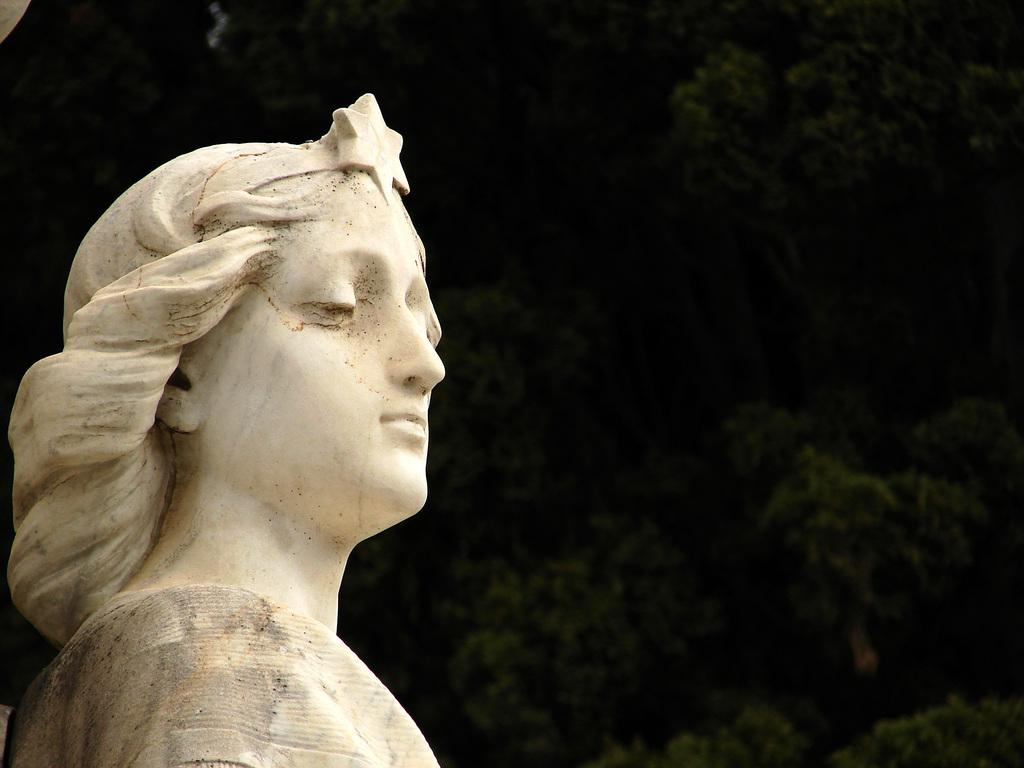What is the main subject in the image? There is a statue in the image. What is the color of the statue? The statue is white in color. What can be seen in the background of the image? There are trees in the background of the image. What type of pot is being held by the statue's hand in the image? There is no pot or hand visible in the image; the statue is stationary and does not appear to be holding anything. 